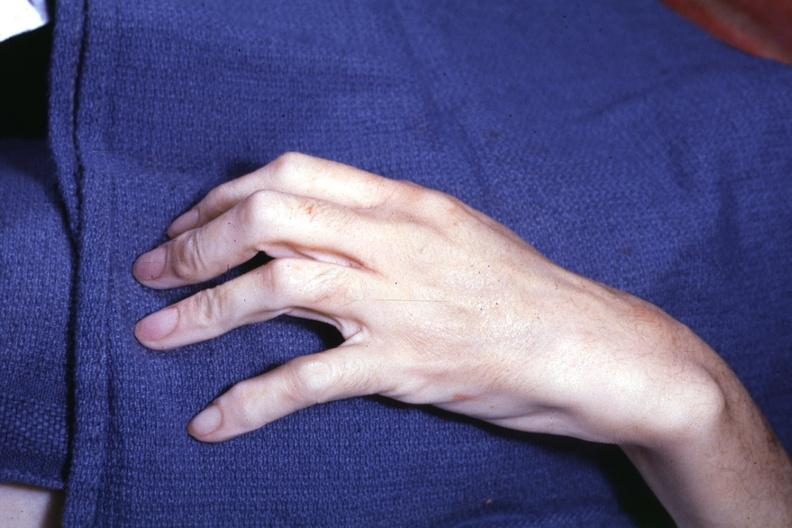does interesting case see other slides?
Answer the question using a single word or phrase. Yes 